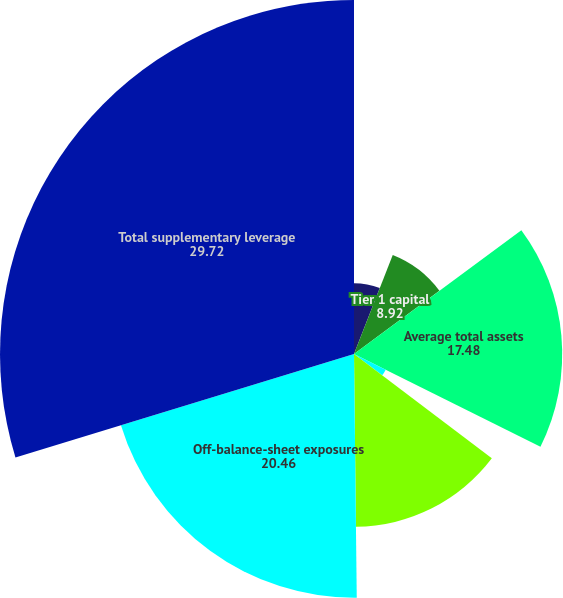Convert chart. <chart><loc_0><loc_0><loc_500><loc_500><pie_chart><fcel>in millions<fcel>Tier 1 capital<fcel>Average total assets<fcel>Deductions from Tier 1 capital<fcel>Average adjusted total assets<fcel>Off-balance-sheet exposures<fcel>Total supplementary leverage<fcel>Supplementary leverage ratio<nl><fcel>5.94%<fcel>8.92%<fcel>17.48%<fcel>2.97%<fcel>14.51%<fcel>20.46%<fcel>29.72%<fcel>0.0%<nl></chart> 